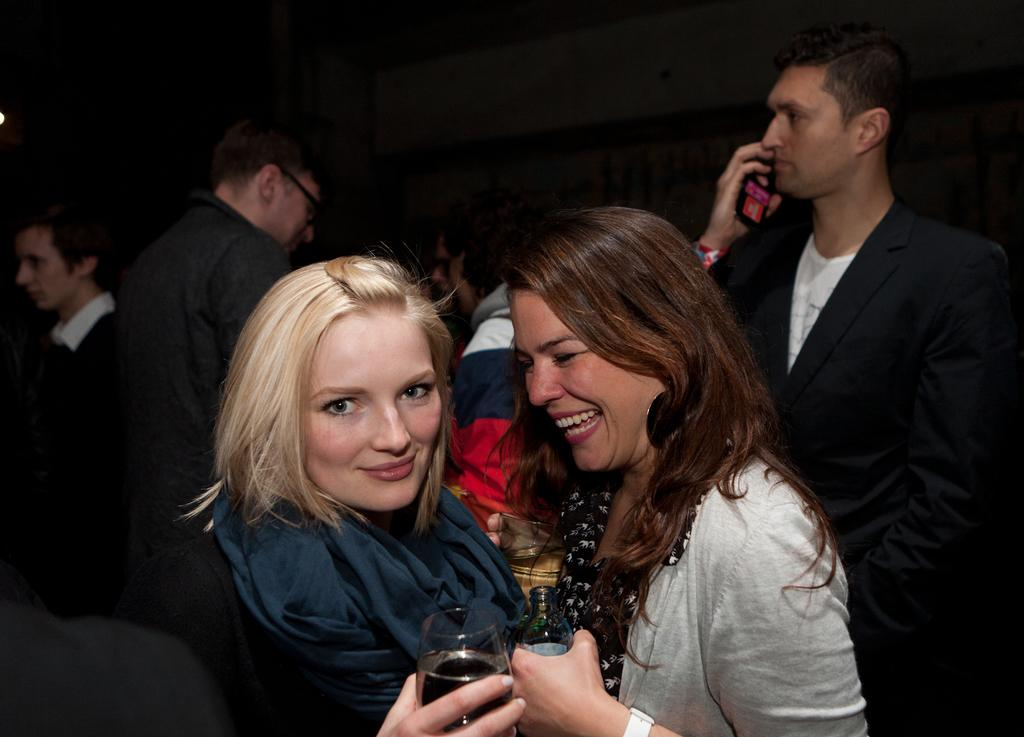How many women are in the image? There are two women in the image. What are the women holding in their hands? The women are carrying glasses in their hands. Can you describe the people behind the women? There is a group of people behind the women. What type of clover is growing in the image? There is no clover present in the image. What scientific experiment is being conducted in the image? There is no scientific experiment being conducted in the image. 